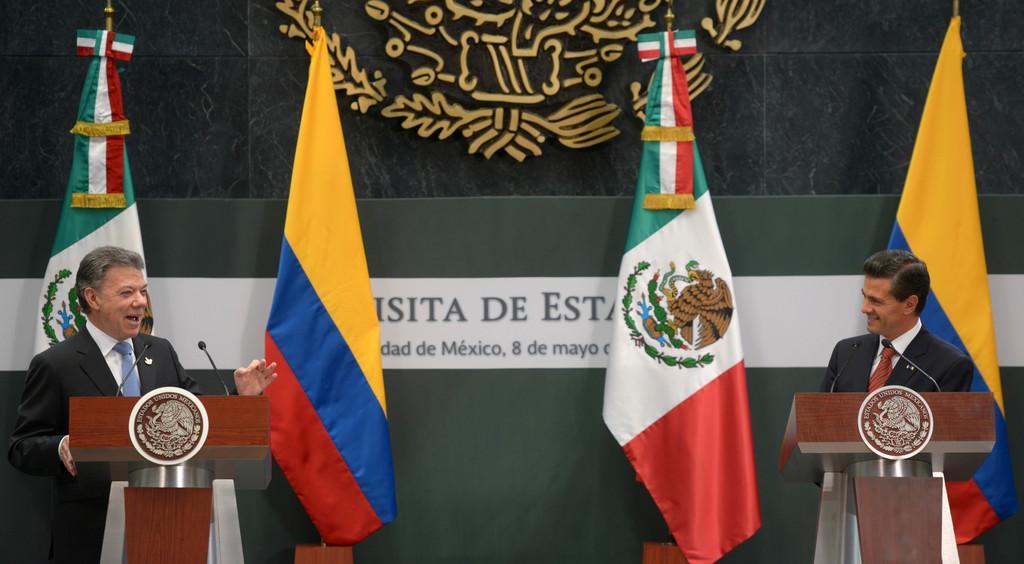Describe this image in one or two sentences. In this image I see 2 men in which both of them are wearing suits which are of black in color and both of them are smiling and I see that both of them are standing in front of the podiums and I see mics on them and I see the logos. In the background I see the flags which are colorful and I see something is written over here. 